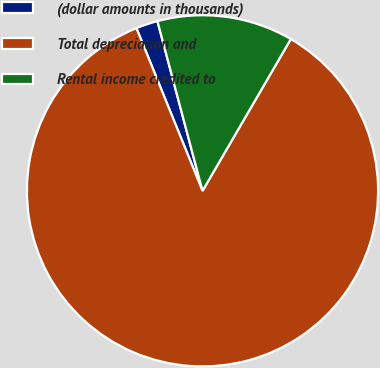Convert chart to OTSL. <chart><loc_0><loc_0><loc_500><loc_500><pie_chart><fcel>(dollar amounts in thousands)<fcel>Total depreciation and<fcel>Rental income credited to<nl><fcel>2.01%<fcel>85.48%<fcel>12.52%<nl></chart> 